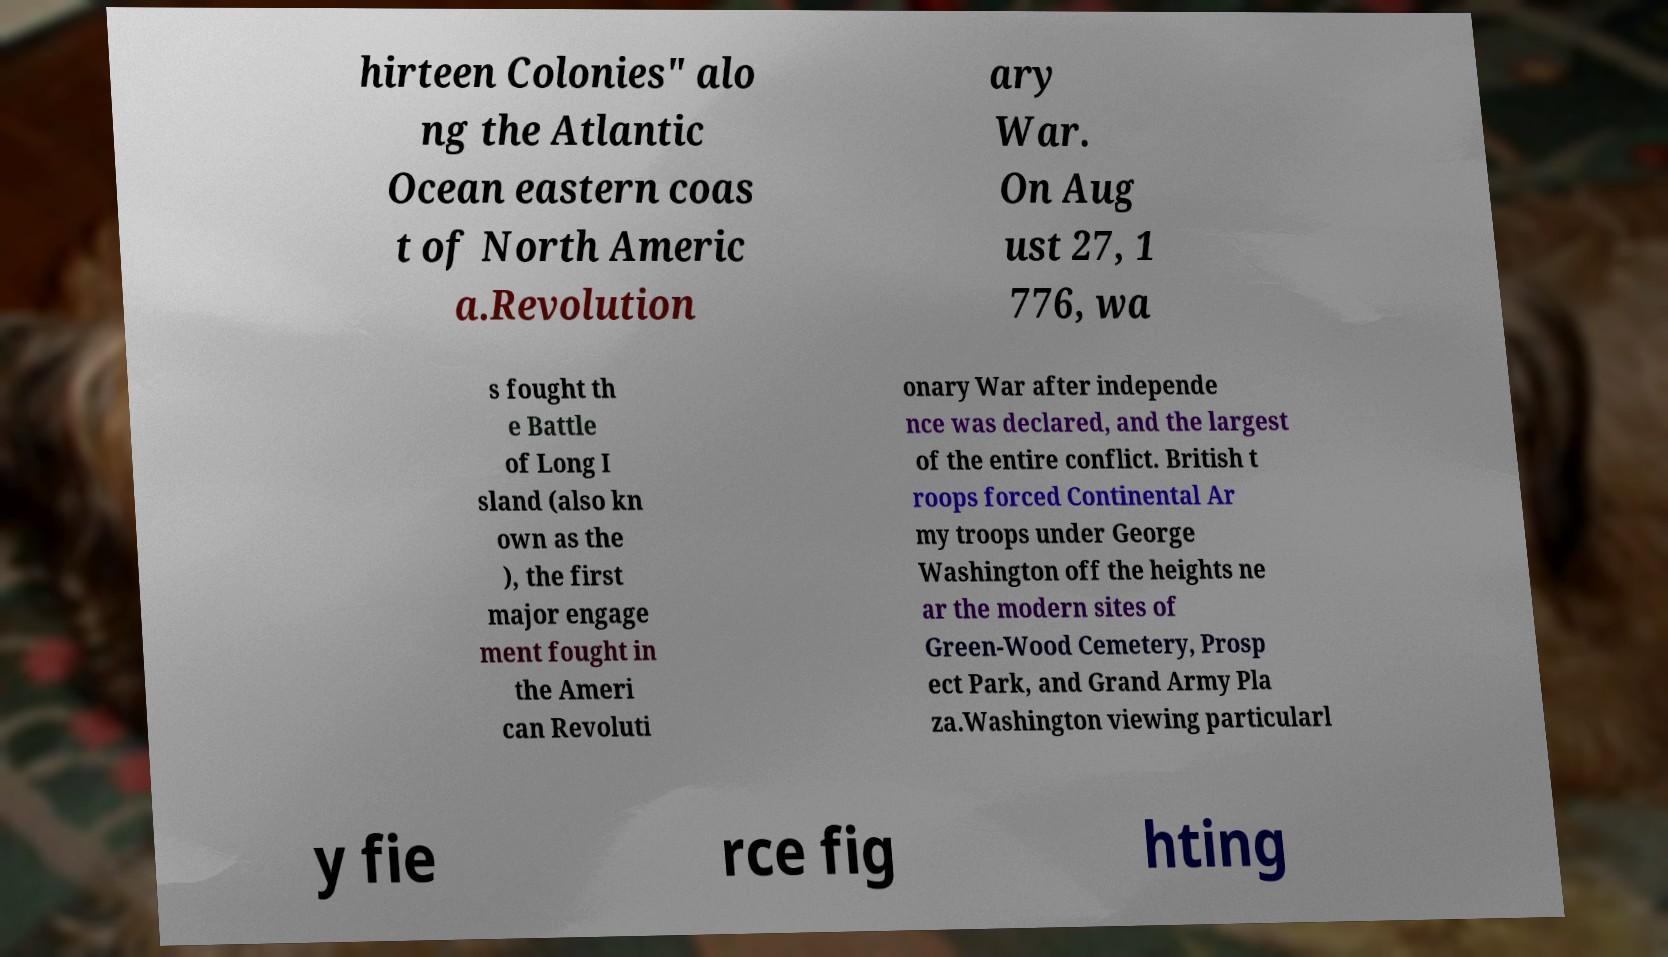There's text embedded in this image that I need extracted. Can you transcribe it verbatim? hirteen Colonies" alo ng the Atlantic Ocean eastern coas t of North Americ a.Revolution ary War. On Aug ust 27, 1 776, wa s fought th e Battle of Long I sland (also kn own as the ), the first major engage ment fought in the Ameri can Revoluti onary War after independe nce was declared, and the largest of the entire conflict. British t roops forced Continental Ar my troops under George Washington off the heights ne ar the modern sites of Green-Wood Cemetery, Prosp ect Park, and Grand Army Pla za.Washington viewing particularl y fie rce fig hting 